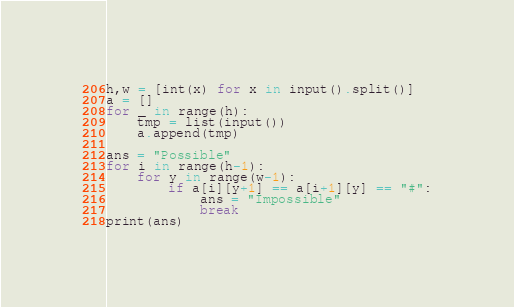Convert code to text. <code><loc_0><loc_0><loc_500><loc_500><_Python_>h,w = [int(x) for x in input().split()]
a = []
for _ in range(h):
    tmp = list(input())
    a.append(tmp)

ans = "Possible"
for i in range(h-1):
    for y in range(w-1):
        if a[i][y+1] == a[i+1][y] == "#":
            ans = "Impossible"
            break
print(ans)</code> 